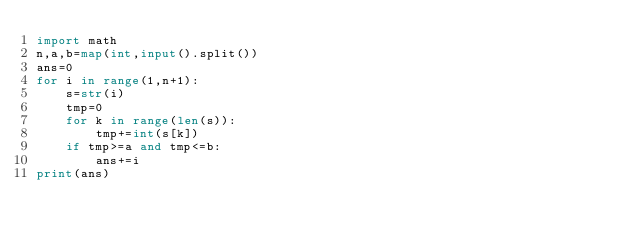<code> <loc_0><loc_0><loc_500><loc_500><_Python_>import math
n,a,b=map(int,input().split())
ans=0
for i in range(1,n+1):
    s=str(i)
    tmp=0
    for k in range(len(s)):
        tmp+=int(s[k])
    if tmp>=a and tmp<=b:
        ans+=i
print(ans)</code> 